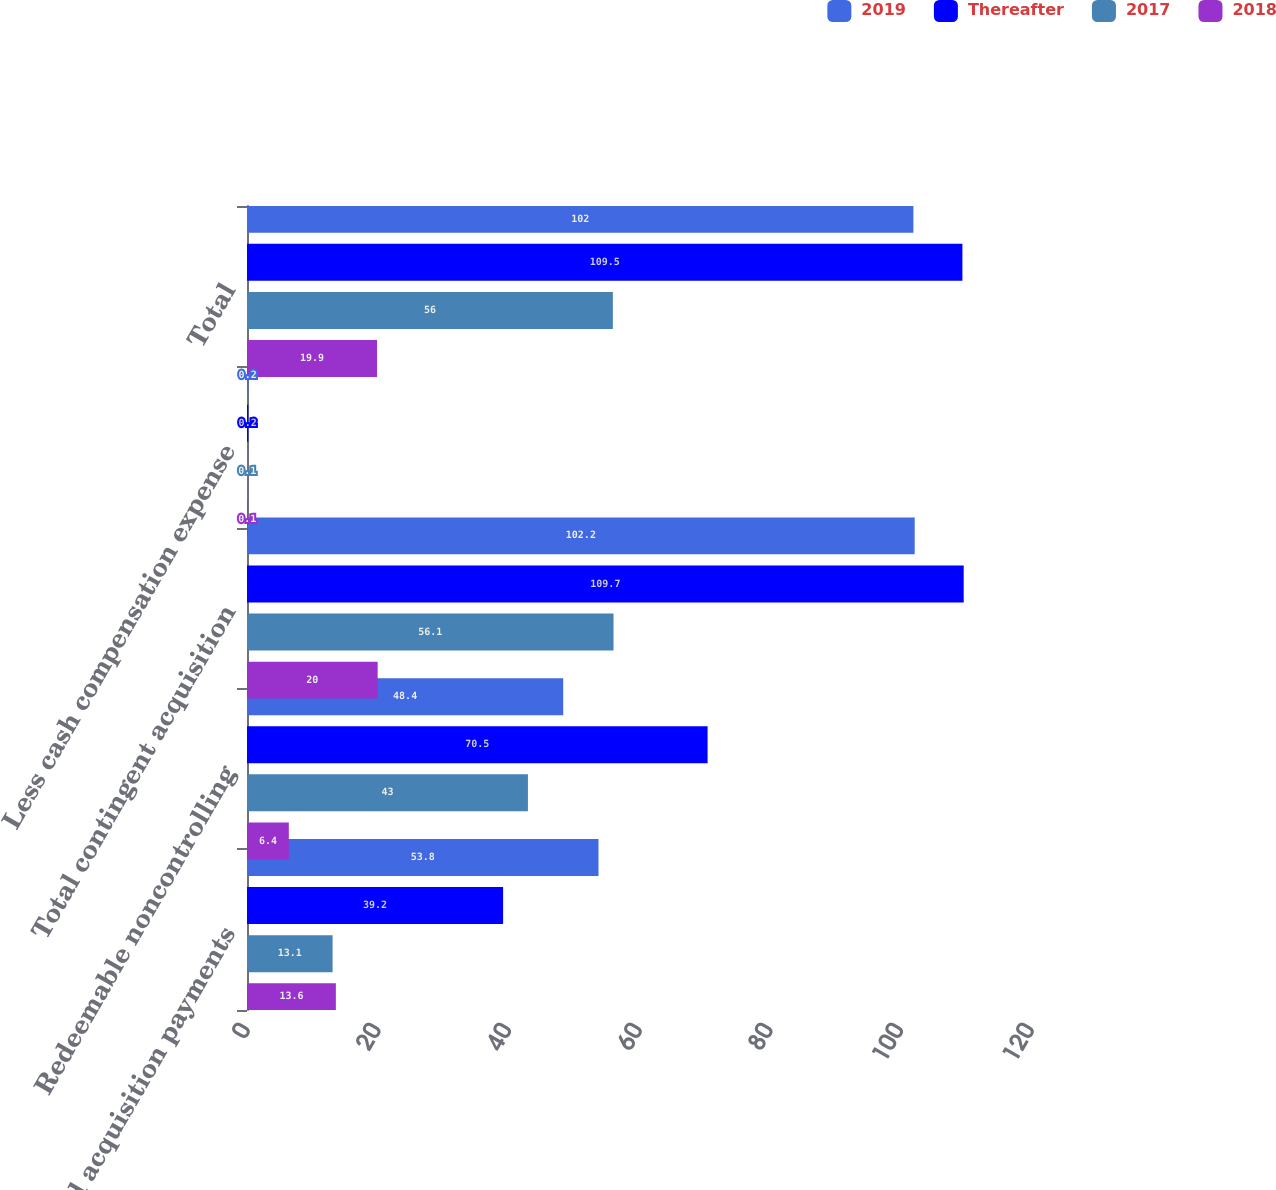<chart> <loc_0><loc_0><loc_500><loc_500><stacked_bar_chart><ecel><fcel>Deferred acquisition payments<fcel>Redeemable noncontrolling<fcel>Total contingent acquisition<fcel>Less cash compensation expense<fcel>Total<nl><fcel>2019<fcel>53.8<fcel>48.4<fcel>102.2<fcel>0.2<fcel>102<nl><fcel>Thereafter<fcel>39.2<fcel>70.5<fcel>109.7<fcel>0.2<fcel>109.5<nl><fcel>2017<fcel>13.1<fcel>43<fcel>56.1<fcel>0.1<fcel>56<nl><fcel>2018<fcel>13.6<fcel>6.4<fcel>20<fcel>0.1<fcel>19.9<nl></chart> 